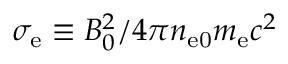<formula> <loc_0><loc_0><loc_500><loc_500>\sigma _ { e } \equiv B _ { 0 } ^ { 2 } / 4 \pi n _ { e 0 } m _ { e } c ^ { 2 }</formula> 